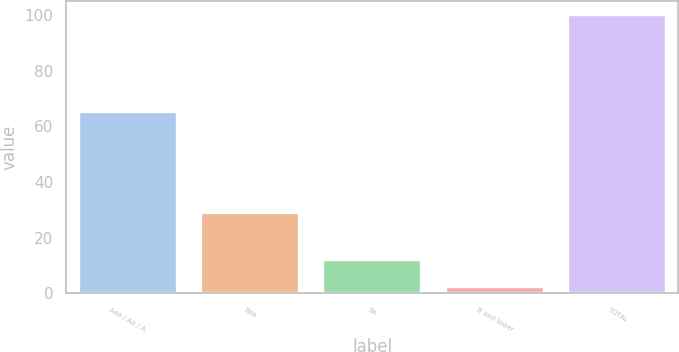Convert chart to OTSL. <chart><loc_0><loc_0><loc_500><loc_500><bar_chart><fcel>Aaa / Aa / A<fcel>Baa<fcel>Ba<fcel>B and lower<fcel>TOTAL<nl><fcel>65<fcel>28.9<fcel>12.07<fcel>2.3<fcel>100<nl></chart> 